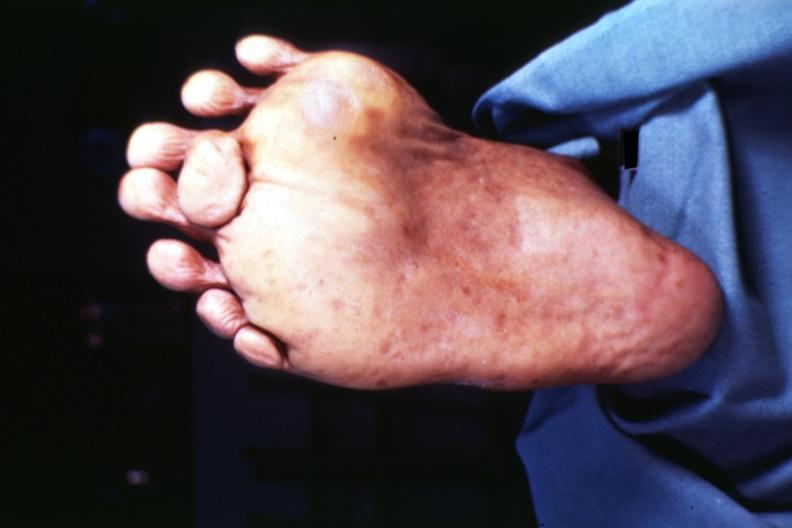re extremities present?
Answer the question using a single word or phrase. Yes 